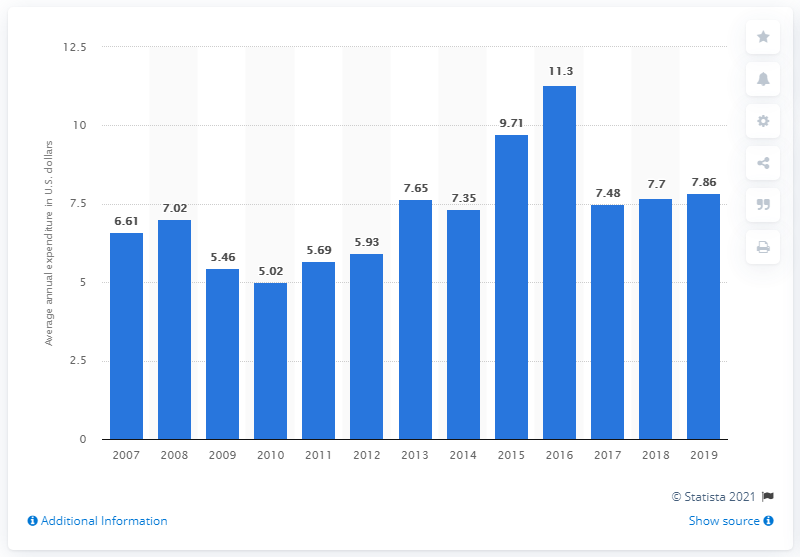Draw attention to some important aspects in this diagram. In 2019, the average expenditure on refrigerators and freezers per consumer unit in the United States was $7.86. 